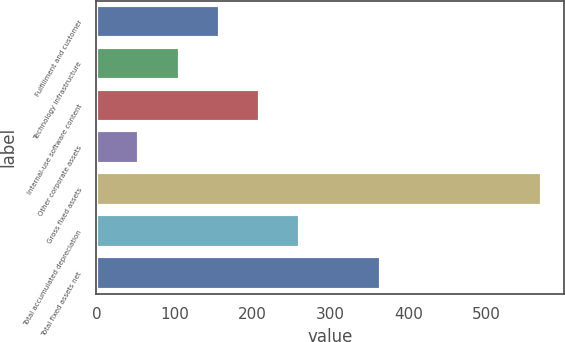Convert chart. <chart><loc_0><loc_0><loc_500><loc_500><bar_chart><fcel>Fulfillment and customer<fcel>Technology infrastructure<fcel>Internal-use software content<fcel>Other corporate assets<fcel>Gross fixed assets<fcel>Total accumulated depreciation<fcel>Total fixed assets net<nl><fcel>158.2<fcel>106.6<fcel>209.8<fcel>55<fcel>571<fcel>261.4<fcel>364.6<nl></chart> 